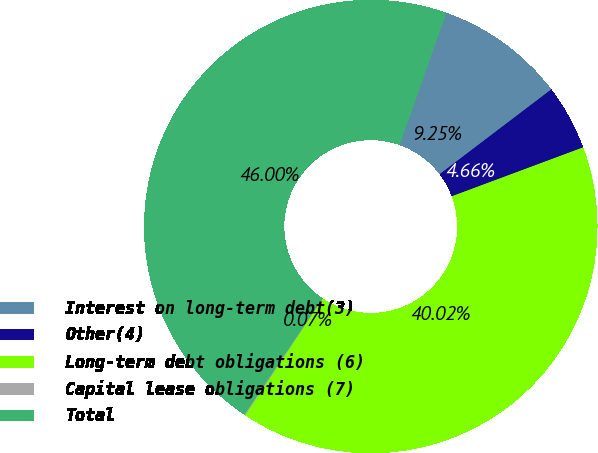Convert chart to OTSL. <chart><loc_0><loc_0><loc_500><loc_500><pie_chart><fcel>Interest on long-term debt(3)<fcel>Other(4)<fcel>Long-term debt obligations (6)<fcel>Capital lease obligations (7)<fcel>Total<nl><fcel>9.25%<fcel>4.66%<fcel>40.02%<fcel>0.07%<fcel>46.0%<nl></chart> 